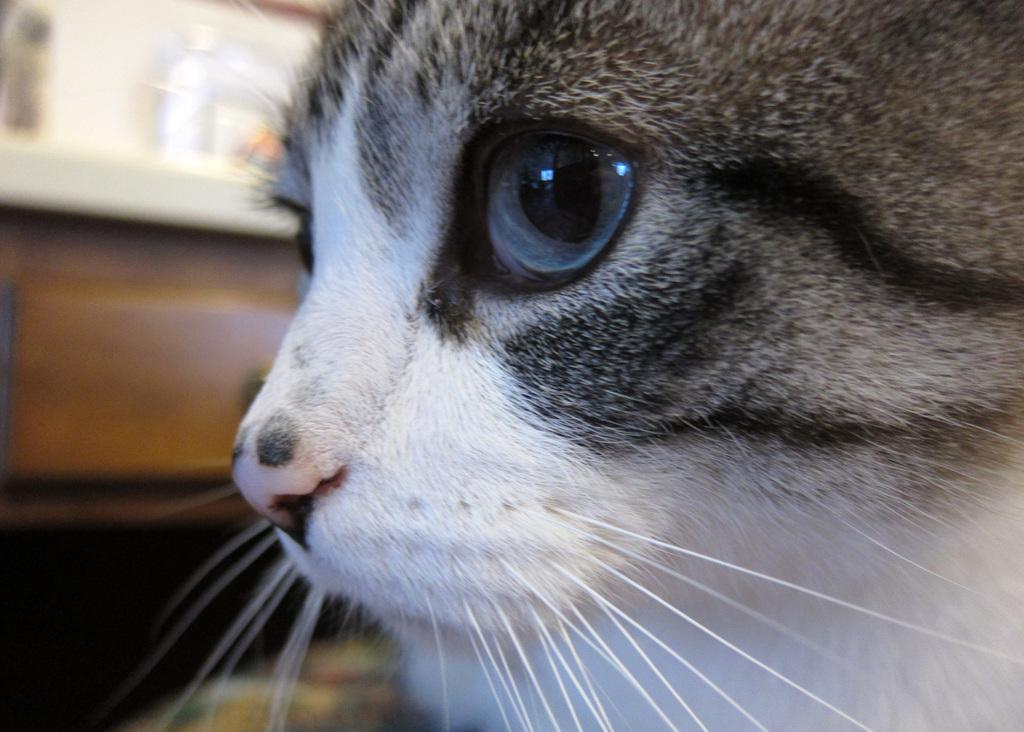What type of animal is in the image? There is a cat in the image. Can you describe the background of the image? The background of the image is blurry. What is the cat doing to the throat of the person in the image? There is no person present in the image, only a cat. The cat is not interacting with a throat or any other body part. 